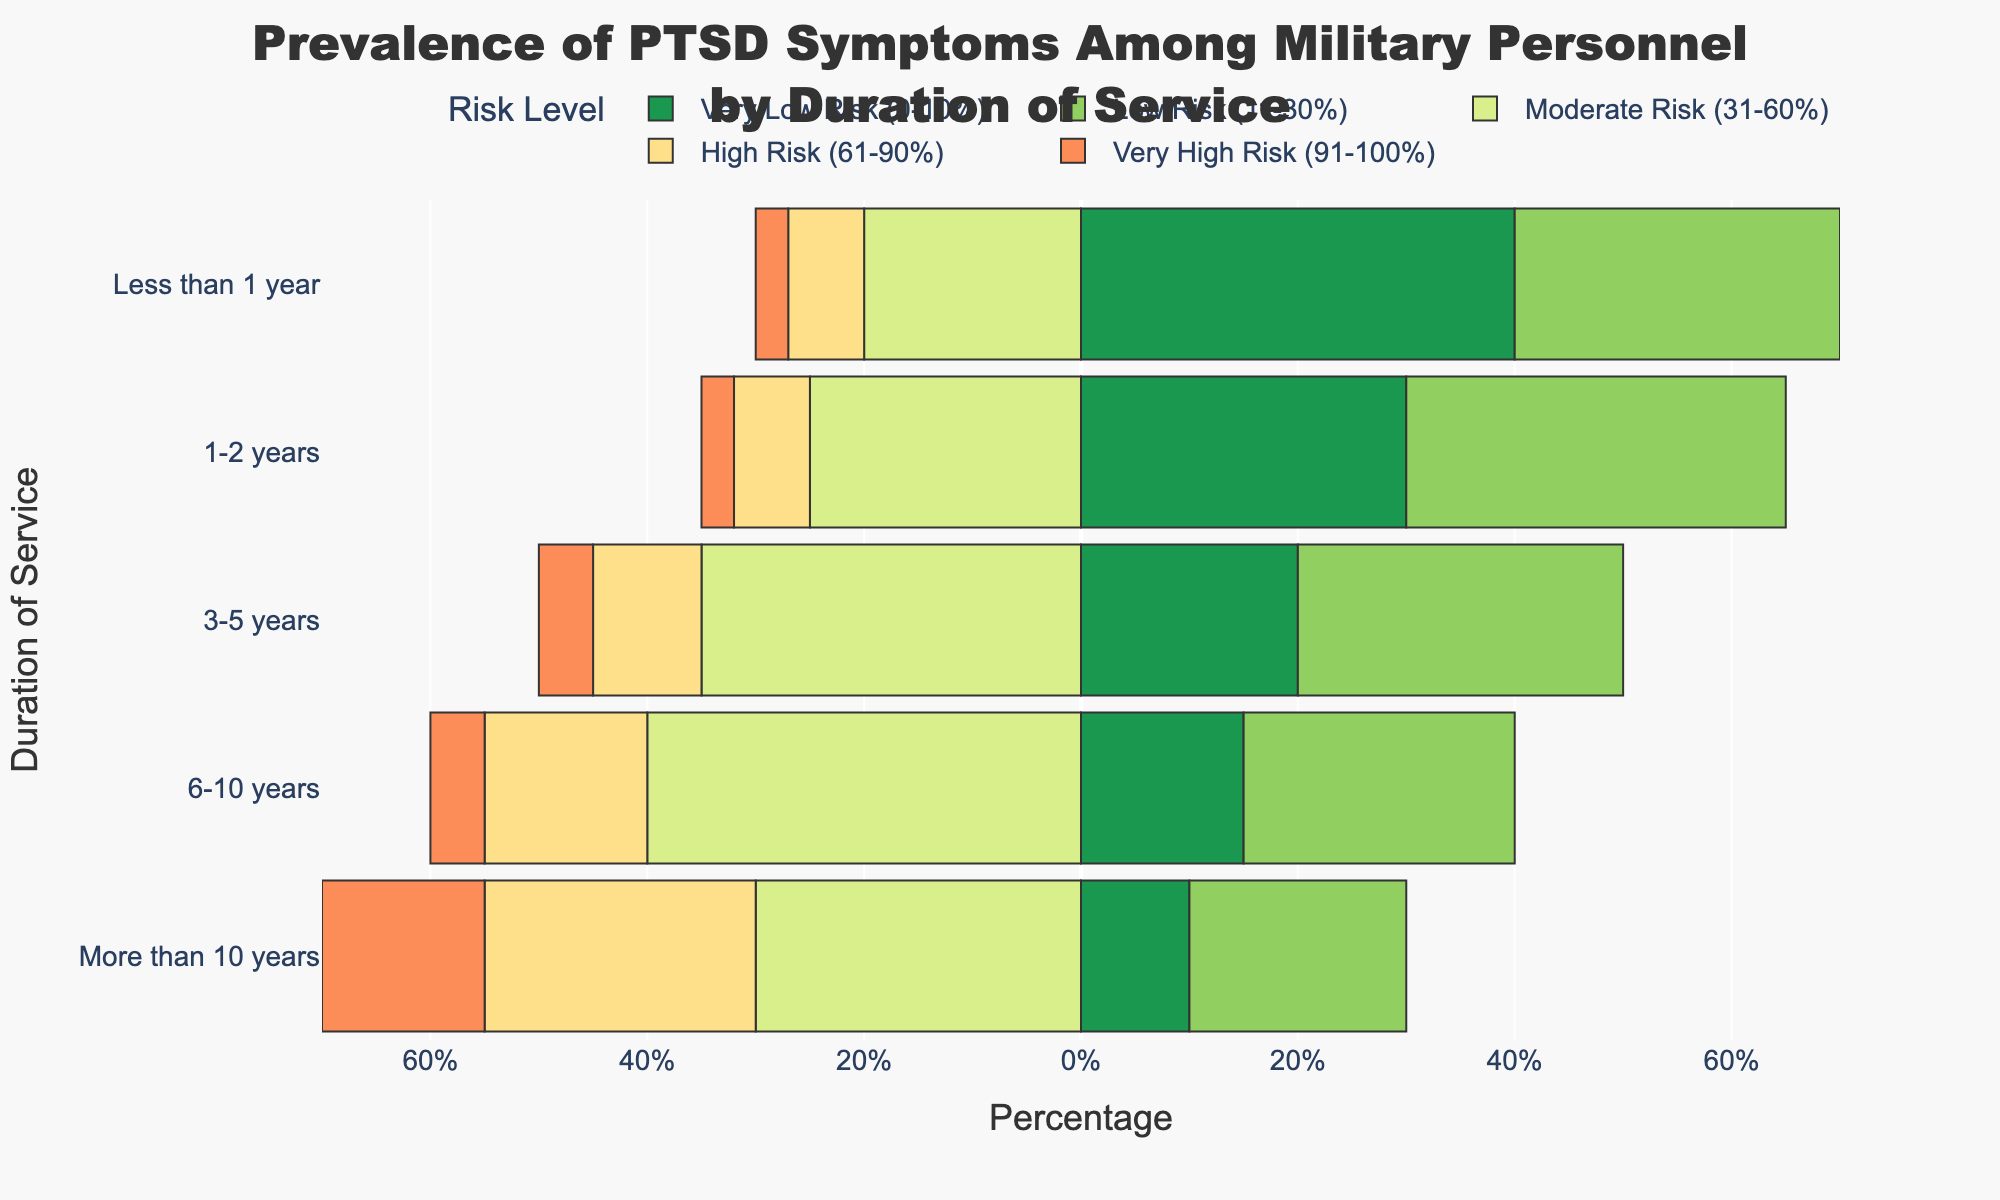What duration of service has the highest percentage of military personnel in the "Very High Risk" category? Look at the "Very High Risk" bars in the chart. The longest bar corresponds to "More than 10 years" with 15%.
Answer: More than 10 years Which duration of service shows the lowest percentage of personnel in the "Very Low Risk" category? Look at the "Very Low Risk" bars. The shortest bar is for "More than 10 years," which is 10%.
Answer: More than 10 years How does the percentage of personnel in the "Moderate Risk" category change with increasing duration of service? Observe the "Moderate Risk" bars. The percentages are 20% for "Less than 1 year," 25% for "1-2 years," 35% for "3-5 years," 40% for "6-10 years," and 30% for "More than 10 years." The trend generally increases till "6-10 years," then decreases.
Answer: Increases initially, then decreases What is the total percentage of personnel in the "High Risk" and "Very High Risk" categories for 3-5 years of service? Sum the percentages of the "High Risk" and "Very High Risk" categories for "3-5 years" of service: 10% + 5%.
Answer: 15% Compare the percentage of personnel in the "Low Risk" category between "1-2 years" and "3-5 years" of service. The "Low Risk" bar for "1-2 years" is 35%, and for "3-5 years" is 30%. 35% is greater than 30%.
Answer: 1-2 years is higher Which color represents the "Very High Risk" category, and how can you identify it? The "Very High Risk" category is the furthest bar to the left in the diverging chart. It is colored in a specific shade. Look at the legend that matches the category name with the color.
Answer: Shade of dark red What is the difference in the percentage of personnel in the "Very Low Risk" category between "Less than 1 year" and "More than 10 years" of service? The "Very Low Risk" bar for "Less than 1 year" is 40%, and for "More than 10 years" is 10%. The difference is 40% - 10%.
Answer: 30% difference Which duration of service has the closest percentage of personnel in the "Moderate Risk" category to those in the "Low Risk" category? Compare the "Moderate Risk" and "Low Risk" bars across all durations. For "3-5 years," the bars are 35% and 30%, which are the closest.
Answer: 3-5 years What is the sum of the percentages of personnel in the "Very Low Risk" and "Low Risk" categories for "6-10 years" of service? Sum the percentages for the "Very Low Risk" and "Low Risk" categories for "6-10 years": 15% + 25%.
Answer: 40% 